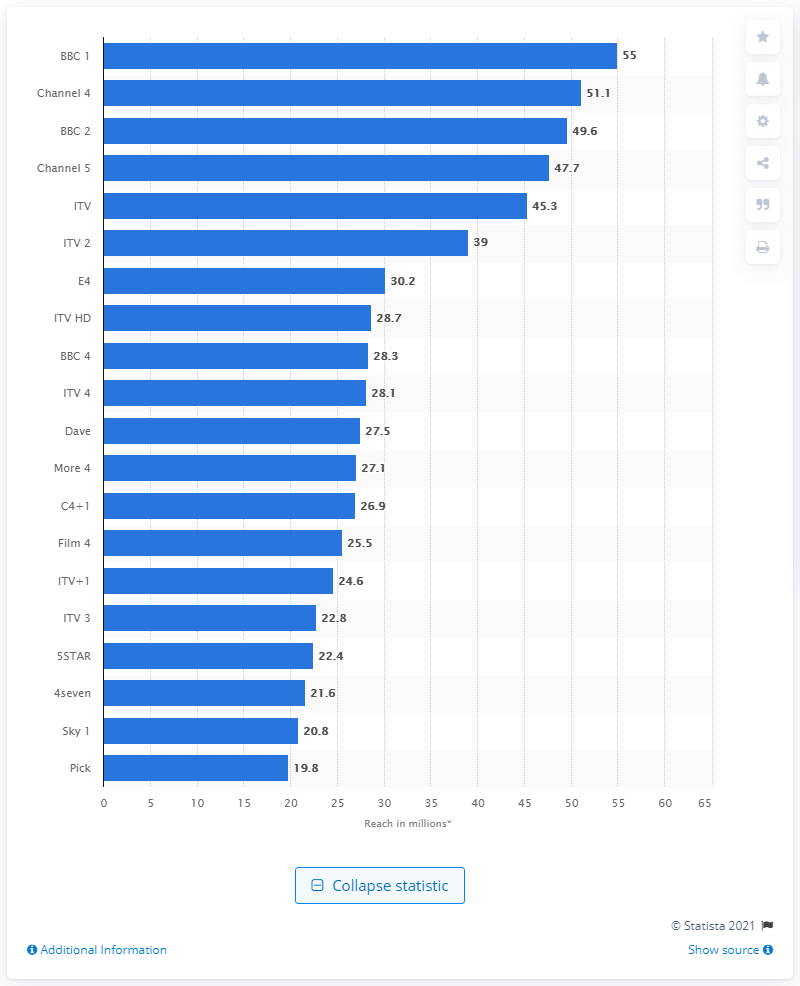List a handful of essential elements in this visual. The number of individuals who viewed BBC 1 during the third quarter of 2019 was 55. As of the third quarter of 2019, Channel 4 was the highest reaching commercial channel in terms of its audience reach. 